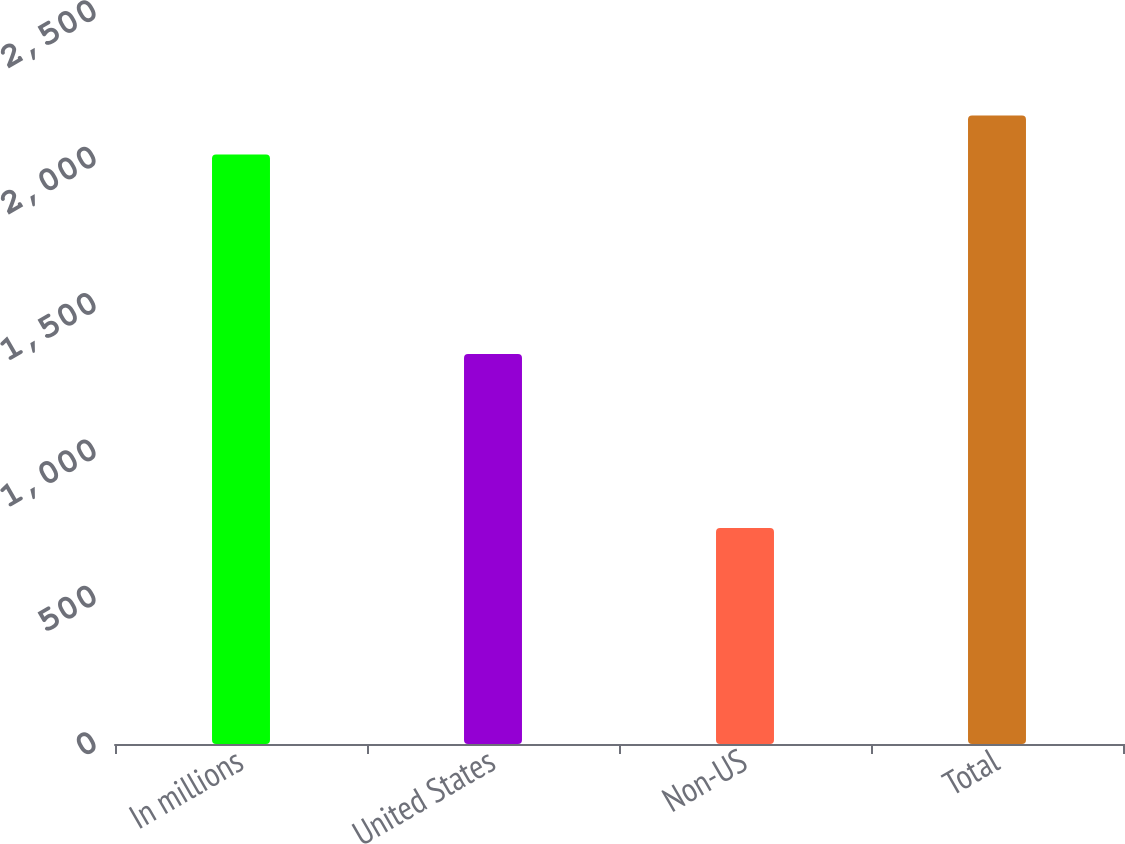<chart> <loc_0><loc_0><loc_500><loc_500><bar_chart><fcel>In millions<fcel>United States<fcel>Non-US<fcel>Total<nl><fcel>2013<fcel>1331.7<fcel>737.9<fcel>2146.17<nl></chart> 